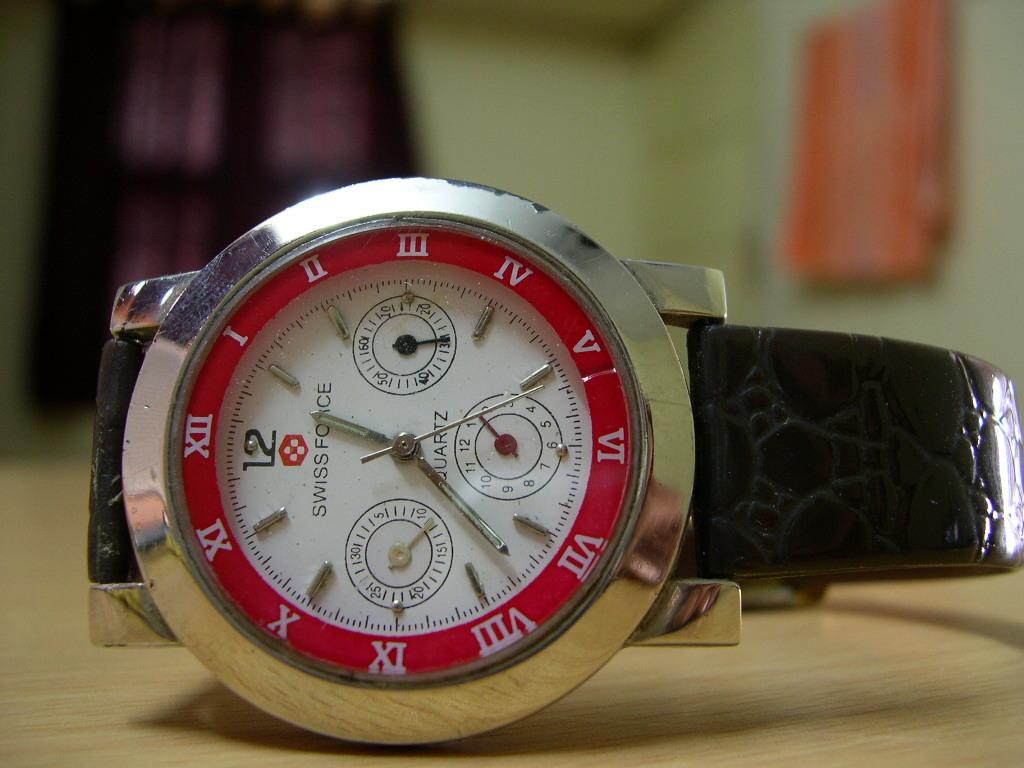Is the watch a swiss watch?
Ensure brevity in your answer.  Yes. What time is it on the clock?
Make the answer very short. 12:37. 